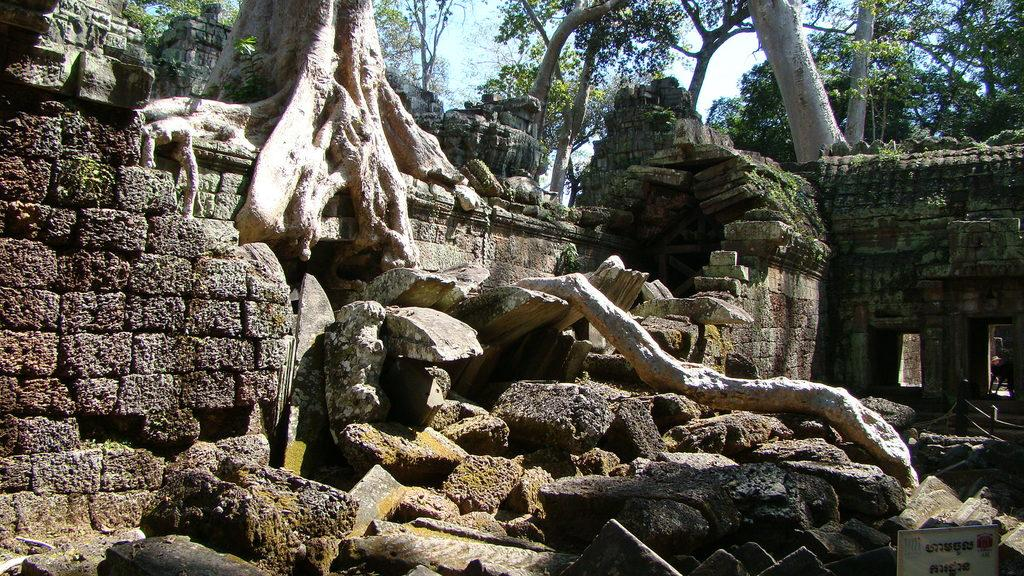What is located in the middle of the image? There are stones in the middle of the image. What type of vegetation can be seen at the top of the image? There are trees at the top of the image. What structure is on the right side of the image? There is a wall on the right side of the image. Can you see a fingerprint on any of the stones in the image? There is no mention of fingerprints or any human interaction with the stones in the image, so it cannot be determined if a fingerprint is present. Is there a lake visible in the image? There is no mention of a lake in the provided facts, so it cannot be determined if a lake is present in the image. 